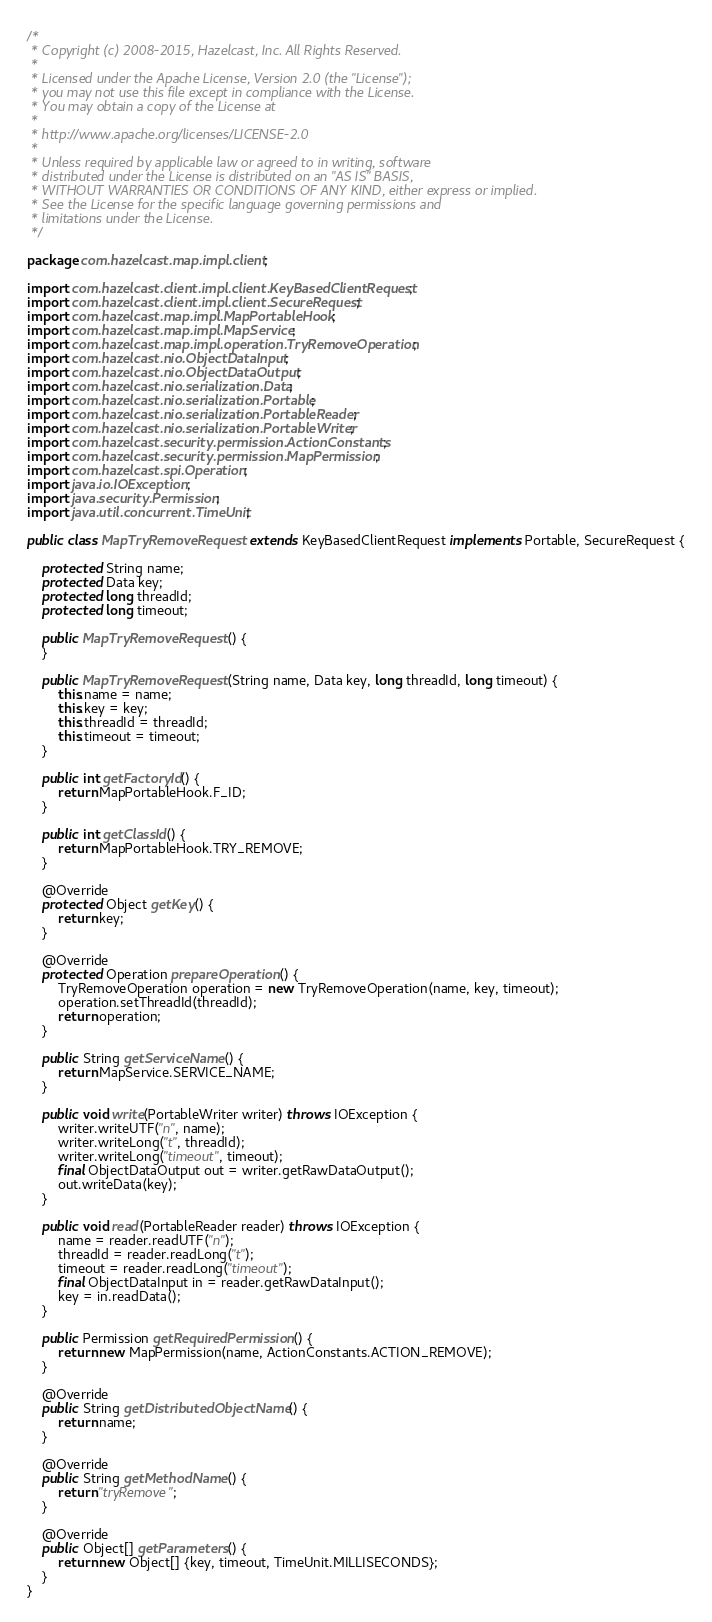<code> <loc_0><loc_0><loc_500><loc_500><_Java_>/*
 * Copyright (c) 2008-2015, Hazelcast, Inc. All Rights Reserved.
 *
 * Licensed under the Apache License, Version 2.0 (the "License");
 * you may not use this file except in compliance with the License.
 * You may obtain a copy of the License at
 *
 * http://www.apache.org/licenses/LICENSE-2.0
 *
 * Unless required by applicable law or agreed to in writing, software
 * distributed under the License is distributed on an "AS IS" BASIS,
 * WITHOUT WARRANTIES OR CONDITIONS OF ANY KIND, either express or implied.
 * See the License for the specific language governing permissions and
 * limitations under the License.
 */

package com.hazelcast.map.impl.client;

import com.hazelcast.client.impl.client.KeyBasedClientRequest;
import com.hazelcast.client.impl.client.SecureRequest;
import com.hazelcast.map.impl.MapPortableHook;
import com.hazelcast.map.impl.MapService;
import com.hazelcast.map.impl.operation.TryRemoveOperation;
import com.hazelcast.nio.ObjectDataInput;
import com.hazelcast.nio.ObjectDataOutput;
import com.hazelcast.nio.serialization.Data;
import com.hazelcast.nio.serialization.Portable;
import com.hazelcast.nio.serialization.PortableReader;
import com.hazelcast.nio.serialization.PortableWriter;
import com.hazelcast.security.permission.ActionConstants;
import com.hazelcast.security.permission.MapPermission;
import com.hazelcast.spi.Operation;
import java.io.IOException;
import java.security.Permission;
import java.util.concurrent.TimeUnit;

public class MapTryRemoveRequest extends KeyBasedClientRequest implements Portable, SecureRequest {

    protected String name;
    protected Data key;
    protected long threadId;
    protected long timeout;

    public MapTryRemoveRequest() {
    }

    public MapTryRemoveRequest(String name, Data key, long threadId, long timeout) {
        this.name = name;
        this.key = key;
        this.threadId = threadId;
        this.timeout = timeout;
    }

    public int getFactoryId() {
        return MapPortableHook.F_ID;
    }

    public int getClassId() {
        return MapPortableHook.TRY_REMOVE;
    }

    @Override
    protected Object getKey() {
        return key;
    }

    @Override
    protected Operation prepareOperation() {
        TryRemoveOperation operation = new TryRemoveOperation(name, key, timeout);
        operation.setThreadId(threadId);
        return operation;
    }

    public String getServiceName() {
        return MapService.SERVICE_NAME;
    }

    public void write(PortableWriter writer) throws IOException {
        writer.writeUTF("n", name);
        writer.writeLong("t", threadId);
        writer.writeLong("timeout", timeout);
        final ObjectDataOutput out = writer.getRawDataOutput();
        out.writeData(key);
    }

    public void read(PortableReader reader) throws IOException {
        name = reader.readUTF("n");
        threadId = reader.readLong("t");
        timeout = reader.readLong("timeout");
        final ObjectDataInput in = reader.getRawDataInput();
        key = in.readData();
    }

    public Permission getRequiredPermission() {
        return new MapPermission(name, ActionConstants.ACTION_REMOVE);
    }

    @Override
    public String getDistributedObjectName() {
        return name;
    }

    @Override
    public String getMethodName() {
        return "tryRemove";
    }

    @Override
    public Object[] getParameters() {
        return new Object[] {key, timeout, TimeUnit.MILLISECONDS};
    }
}
</code> 